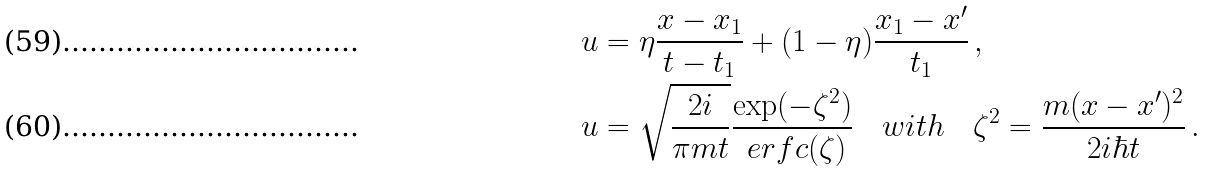<formula> <loc_0><loc_0><loc_500><loc_500>u & = \eta \frac { x - x _ { 1 } } { t - t _ { 1 } } + ( 1 - \eta ) \frac { x _ { 1 } - x ^ { \prime } } { t _ { 1 } } \, , \\ u & = \sqrt { \frac { 2 i } { \pi m t } } \frac { \exp ( - \zeta ^ { 2 } ) } { \ e r f c ( \zeta ) } \quad w i t h \quad \zeta ^ { 2 } = \frac { m ( x - x ^ { \prime } ) ^ { 2 } } { 2 i \hbar { t } } \, .</formula> 